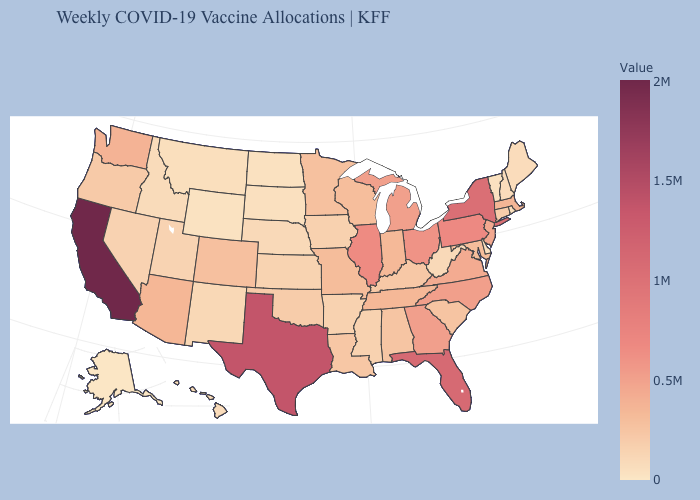Among the states that border Utah , does Arizona have the highest value?
Quick response, please. Yes. Which states have the highest value in the USA?
Write a very short answer. California. Which states have the lowest value in the West?
Answer briefly. Alaska. Among the states that border Minnesota , which have the lowest value?
Quick response, please. North Dakota. Does Texas have a higher value than South Carolina?
Quick response, please. Yes. Does Alabama have the lowest value in the South?
Short answer required. No. Does Michigan have a lower value than Louisiana?
Keep it brief. No. 